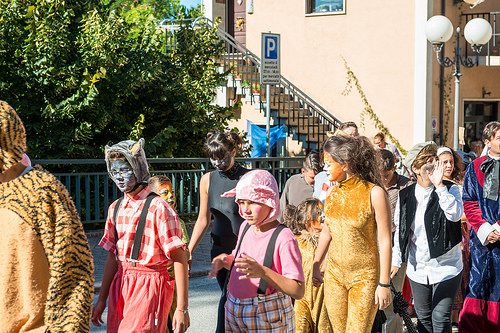<image>
Is there a light above the lady? No. The light is not positioned above the lady. The vertical arrangement shows a different relationship. 